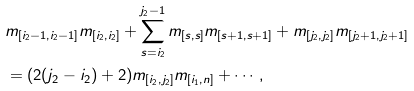Convert formula to latex. <formula><loc_0><loc_0><loc_500><loc_500>& m _ { [ i _ { 2 } - 1 , i _ { 2 } - 1 ] } m _ { [ i _ { 2 } , i _ { 2 } ] } + \sum _ { s = i _ { 2 } } ^ { j _ { 2 } - 1 } m _ { [ s , s ] } m _ { [ s + 1 , s + 1 ] } + m _ { [ j _ { 2 } , j _ { 2 } ] } m _ { [ j _ { 2 } + 1 , j _ { 2 } + 1 ] } \\ & = ( 2 ( j _ { 2 } - i _ { 2 } ) + 2 ) m _ { [ i _ { 2 } , j _ { 2 } ] } m _ { [ i _ { 1 } , n ] } + \cdots ,</formula> 